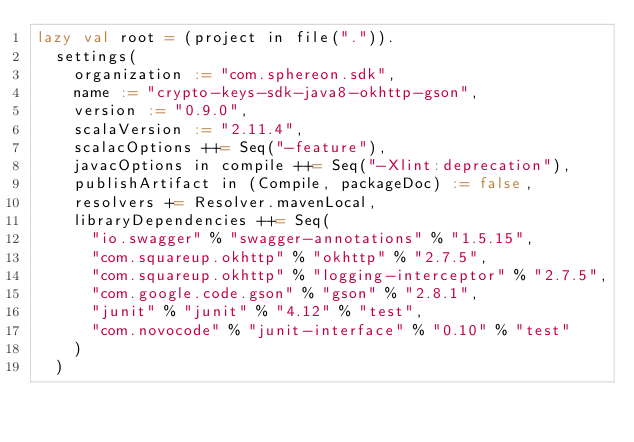<code> <loc_0><loc_0><loc_500><loc_500><_Scala_>lazy val root = (project in file(".")).
  settings(
    organization := "com.sphereon.sdk",
    name := "crypto-keys-sdk-java8-okhttp-gson",
    version := "0.9.0",
    scalaVersion := "2.11.4",
    scalacOptions ++= Seq("-feature"),
    javacOptions in compile ++= Seq("-Xlint:deprecation"),
    publishArtifact in (Compile, packageDoc) := false,
    resolvers += Resolver.mavenLocal,
    libraryDependencies ++= Seq(
      "io.swagger" % "swagger-annotations" % "1.5.15",
      "com.squareup.okhttp" % "okhttp" % "2.7.5",
      "com.squareup.okhttp" % "logging-interceptor" % "2.7.5",
      "com.google.code.gson" % "gson" % "2.8.1",
      "junit" % "junit" % "4.12" % "test",
      "com.novocode" % "junit-interface" % "0.10" % "test"
    )
  )
</code> 